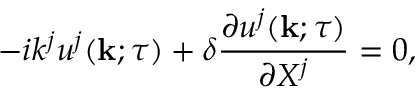Convert formula to latex. <formula><loc_0><loc_0><loc_500><loc_500>- i k ^ { j } u ^ { j } ( { k } ; \tau ) + \delta \frac { \partial u ^ { j } ( { k } ; \tau ) } { \partial X ^ { j } } = 0 ,</formula> 